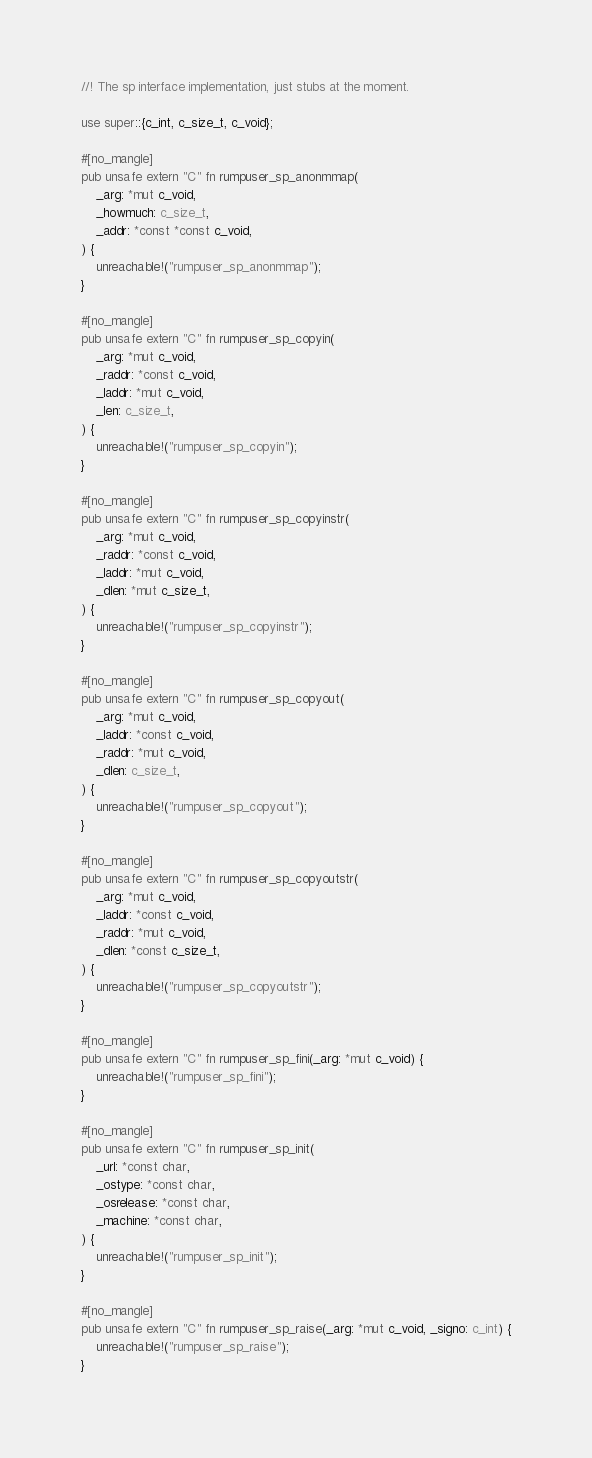<code> <loc_0><loc_0><loc_500><loc_500><_Rust_>//! The sp interface implementation, just stubs at the moment.

use super::{c_int, c_size_t, c_void};

#[no_mangle]
pub unsafe extern "C" fn rumpuser_sp_anonmmap(
    _arg: *mut c_void,
    _howmuch: c_size_t,
    _addr: *const *const c_void,
) {
    unreachable!("rumpuser_sp_anonmmap");
}

#[no_mangle]
pub unsafe extern "C" fn rumpuser_sp_copyin(
    _arg: *mut c_void,
    _raddr: *const c_void,
    _laddr: *mut c_void,
    _len: c_size_t,
) {
    unreachable!("rumpuser_sp_copyin");
}

#[no_mangle]
pub unsafe extern "C" fn rumpuser_sp_copyinstr(
    _arg: *mut c_void,
    _raddr: *const c_void,
    _laddr: *mut c_void,
    _dlen: *mut c_size_t,
) {
    unreachable!("rumpuser_sp_copyinstr");
}

#[no_mangle]
pub unsafe extern "C" fn rumpuser_sp_copyout(
    _arg: *mut c_void,
    _laddr: *const c_void,
    _raddr: *mut c_void,
    _dlen: c_size_t,
) {
    unreachable!("rumpuser_sp_copyout");
}

#[no_mangle]
pub unsafe extern "C" fn rumpuser_sp_copyoutstr(
    _arg: *mut c_void,
    _laddr: *const c_void,
    _raddr: *mut c_void,
    _dlen: *const c_size_t,
) {
    unreachable!("rumpuser_sp_copyoutstr");
}

#[no_mangle]
pub unsafe extern "C" fn rumpuser_sp_fini(_arg: *mut c_void) {
    unreachable!("rumpuser_sp_fini");
}

#[no_mangle]
pub unsafe extern "C" fn rumpuser_sp_init(
    _url: *const char,
    _ostype: *const char,
    _osrelease: *const char,
    _machine: *const char,
) {
    unreachable!("rumpuser_sp_init");
}

#[no_mangle]
pub unsafe extern "C" fn rumpuser_sp_raise(_arg: *mut c_void, _signo: c_int) {
    unreachable!("rumpuser_sp_raise");
}
</code> 